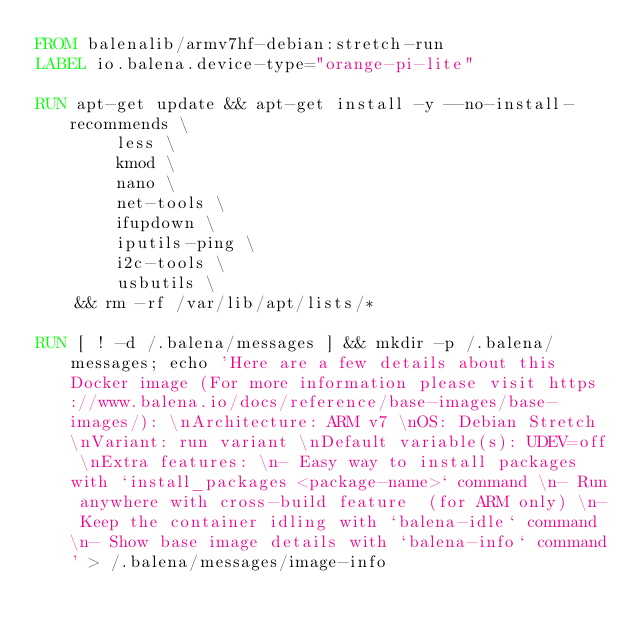<code> <loc_0><loc_0><loc_500><loc_500><_Dockerfile_>FROM balenalib/armv7hf-debian:stretch-run
LABEL io.balena.device-type="orange-pi-lite"

RUN apt-get update && apt-get install -y --no-install-recommends \
		less \
		kmod \
		nano \
		net-tools \
		ifupdown \
		iputils-ping \
		i2c-tools \
		usbutils \
	&& rm -rf /var/lib/apt/lists/*

RUN [ ! -d /.balena/messages ] && mkdir -p /.balena/messages; echo 'Here are a few details about this Docker image (For more information please visit https://www.balena.io/docs/reference/base-images/base-images/): \nArchitecture: ARM v7 \nOS: Debian Stretch \nVariant: run variant \nDefault variable(s): UDEV=off \nExtra features: \n- Easy way to install packages with `install_packages <package-name>` command \n- Run anywhere with cross-build feature  (for ARM only) \n- Keep the container idling with `balena-idle` command \n- Show base image details with `balena-info` command' > /.balena/messages/image-info</code> 